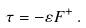<formula> <loc_0><loc_0><loc_500><loc_500>\tau = - \varepsilon F ^ { + } \, .</formula> 